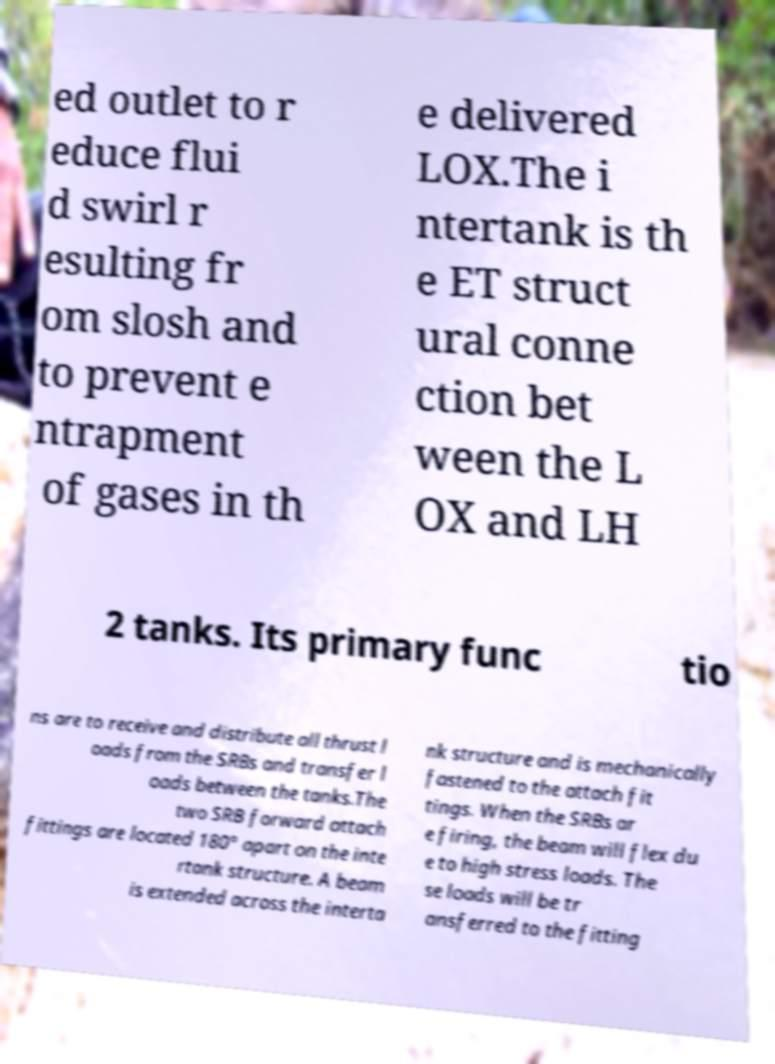Could you extract and type out the text from this image? ed outlet to r educe flui d swirl r esulting fr om slosh and to prevent e ntrapment of gases in th e delivered LOX.The i ntertank is th e ET struct ural conne ction bet ween the L OX and LH 2 tanks. Its primary func tio ns are to receive and distribute all thrust l oads from the SRBs and transfer l oads between the tanks.The two SRB forward attach fittings are located 180° apart on the inte rtank structure. A beam is extended across the interta nk structure and is mechanically fastened to the attach fit tings. When the SRBs ar e firing, the beam will flex du e to high stress loads. The se loads will be tr ansferred to the fitting 